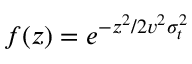Convert formula to latex. <formula><loc_0><loc_0><loc_500><loc_500>f ( z ) = e ^ { - z ^ { 2 } / 2 v ^ { 2 } \sigma _ { t } ^ { 2 } }</formula> 